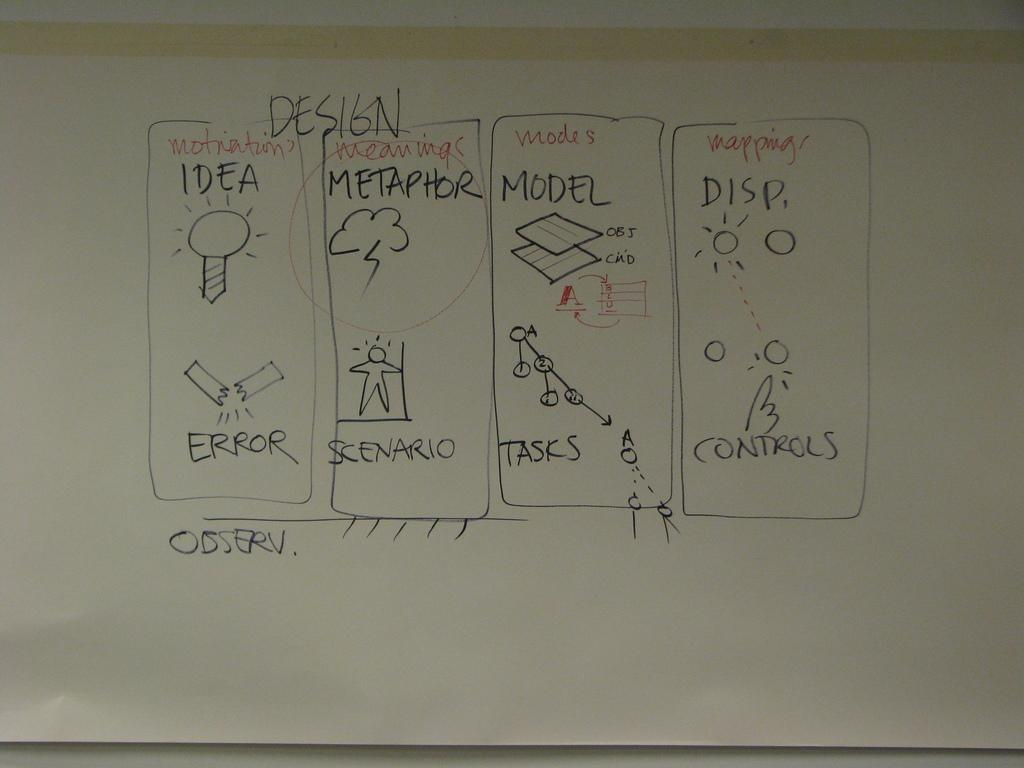<image>
Present a compact description of the photo's key features. A piece of paper with the word Metaphor circled. 